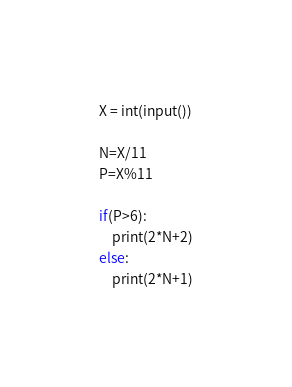<code> <loc_0><loc_0><loc_500><loc_500><_Python_>X = int(input())

N=X/11
P=X%11

if(P>6):
    print(2*N+2)
else:
    print(2*N+1)</code> 